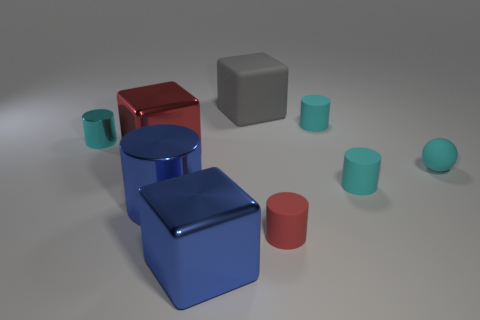Does the blue metal block have the same size as the red matte thing in front of the tiny sphere?
Your response must be concise. No. Is there a rubber ball that has the same size as the gray matte object?
Give a very brief answer. No. What number of other objects are the same material as the red block?
Ensure brevity in your answer.  3. What is the color of the cylinder that is both behind the cyan sphere and on the right side of the big gray matte block?
Give a very brief answer. Cyan. Are the large cube in front of the red metal cube and the tiny cyan cylinder that is on the left side of the large blue metallic cylinder made of the same material?
Keep it short and to the point. Yes. There is a block that is in front of the cyan ball; does it have the same size as the large red metal block?
Provide a succinct answer. Yes. There is a sphere; does it have the same color as the small rubber cylinder that is behind the cyan rubber ball?
Offer a very short reply. Yes. There is a shiny thing that is the same color as the small matte sphere; what is its shape?
Your answer should be compact. Cylinder. There is a small red matte thing; what shape is it?
Your answer should be very brief. Cylinder. Do the matte ball and the large cylinder have the same color?
Give a very brief answer. No. 